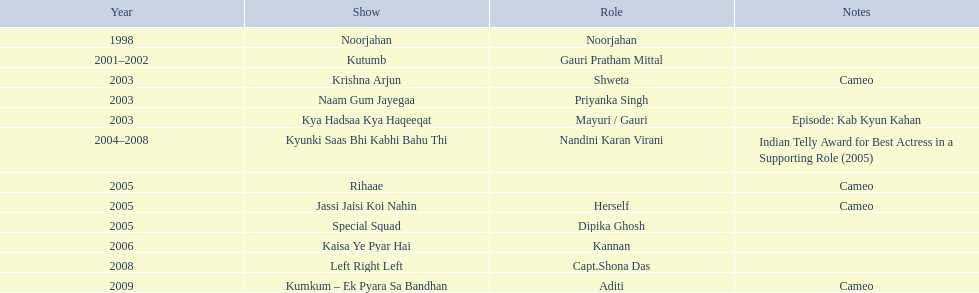What shows was gauri tejwani in? Noorjahan, Kutumb, Krishna Arjun, Naam Gum Jayegaa, Kya Hadsaa Kya Haqeeqat, Kyunki Saas Bhi Kabhi Bahu Thi, Rihaae, Jassi Jaisi Koi Nahin, Special Squad, Kaisa Ye Pyar Hai, Left Right Left, Kumkum – Ek Pyara Sa Bandhan. What were the 2005 shows? Rihaae, Jassi Jaisi Koi Nahin, Special Squad. Which were cameos? Rihaae, Jassi Jaisi Koi Nahin. Of which of these it was not rihaee? Jassi Jaisi Koi Nahin. 